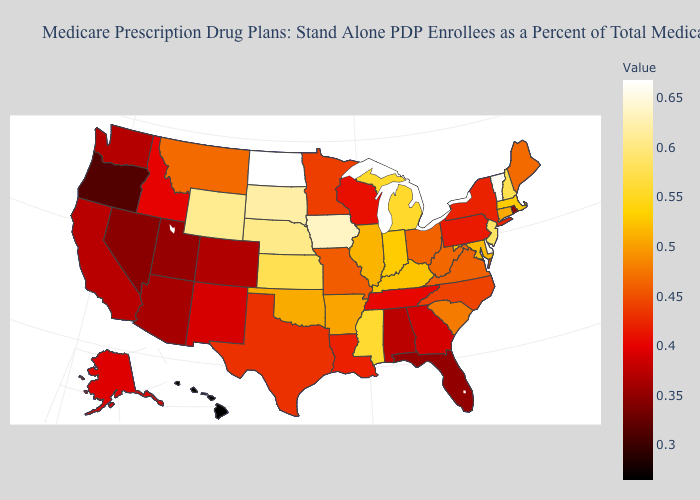Among the states that border New Jersey , does Pennsylvania have the highest value?
Write a very short answer. No. Does Hawaii have the lowest value in the USA?
Be succinct. Yes. Does the map have missing data?
Keep it brief. No. Does Connecticut have the highest value in the Northeast?
Quick response, please. No. Which states hav the highest value in the South?
Be succinct. Delaware. 